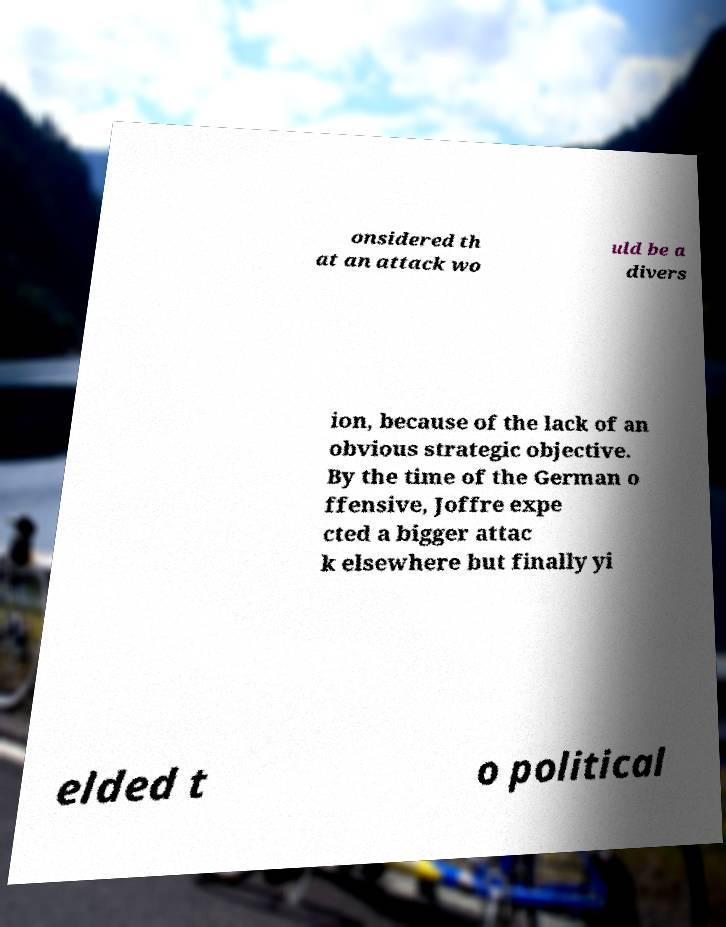I need the written content from this picture converted into text. Can you do that? onsidered th at an attack wo uld be a divers ion, because of the lack of an obvious strategic objective. By the time of the German o ffensive, Joffre expe cted a bigger attac k elsewhere but finally yi elded t o political 